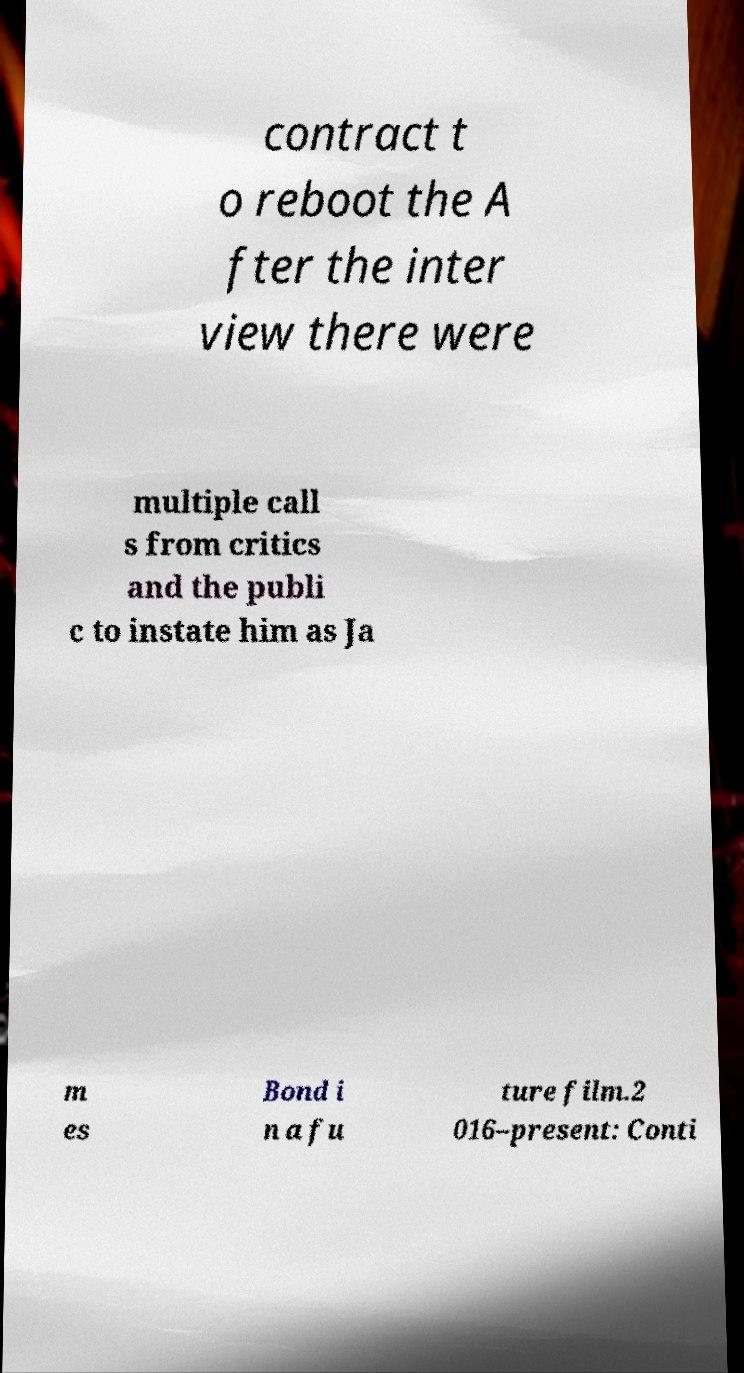Could you extract and type out the text from this image? contract t o reboot the A fter the inter view there were multiple call s from critics and the publi c to instate him as Ja m es Bond i n a fu ture film.2 016–present: Conti 